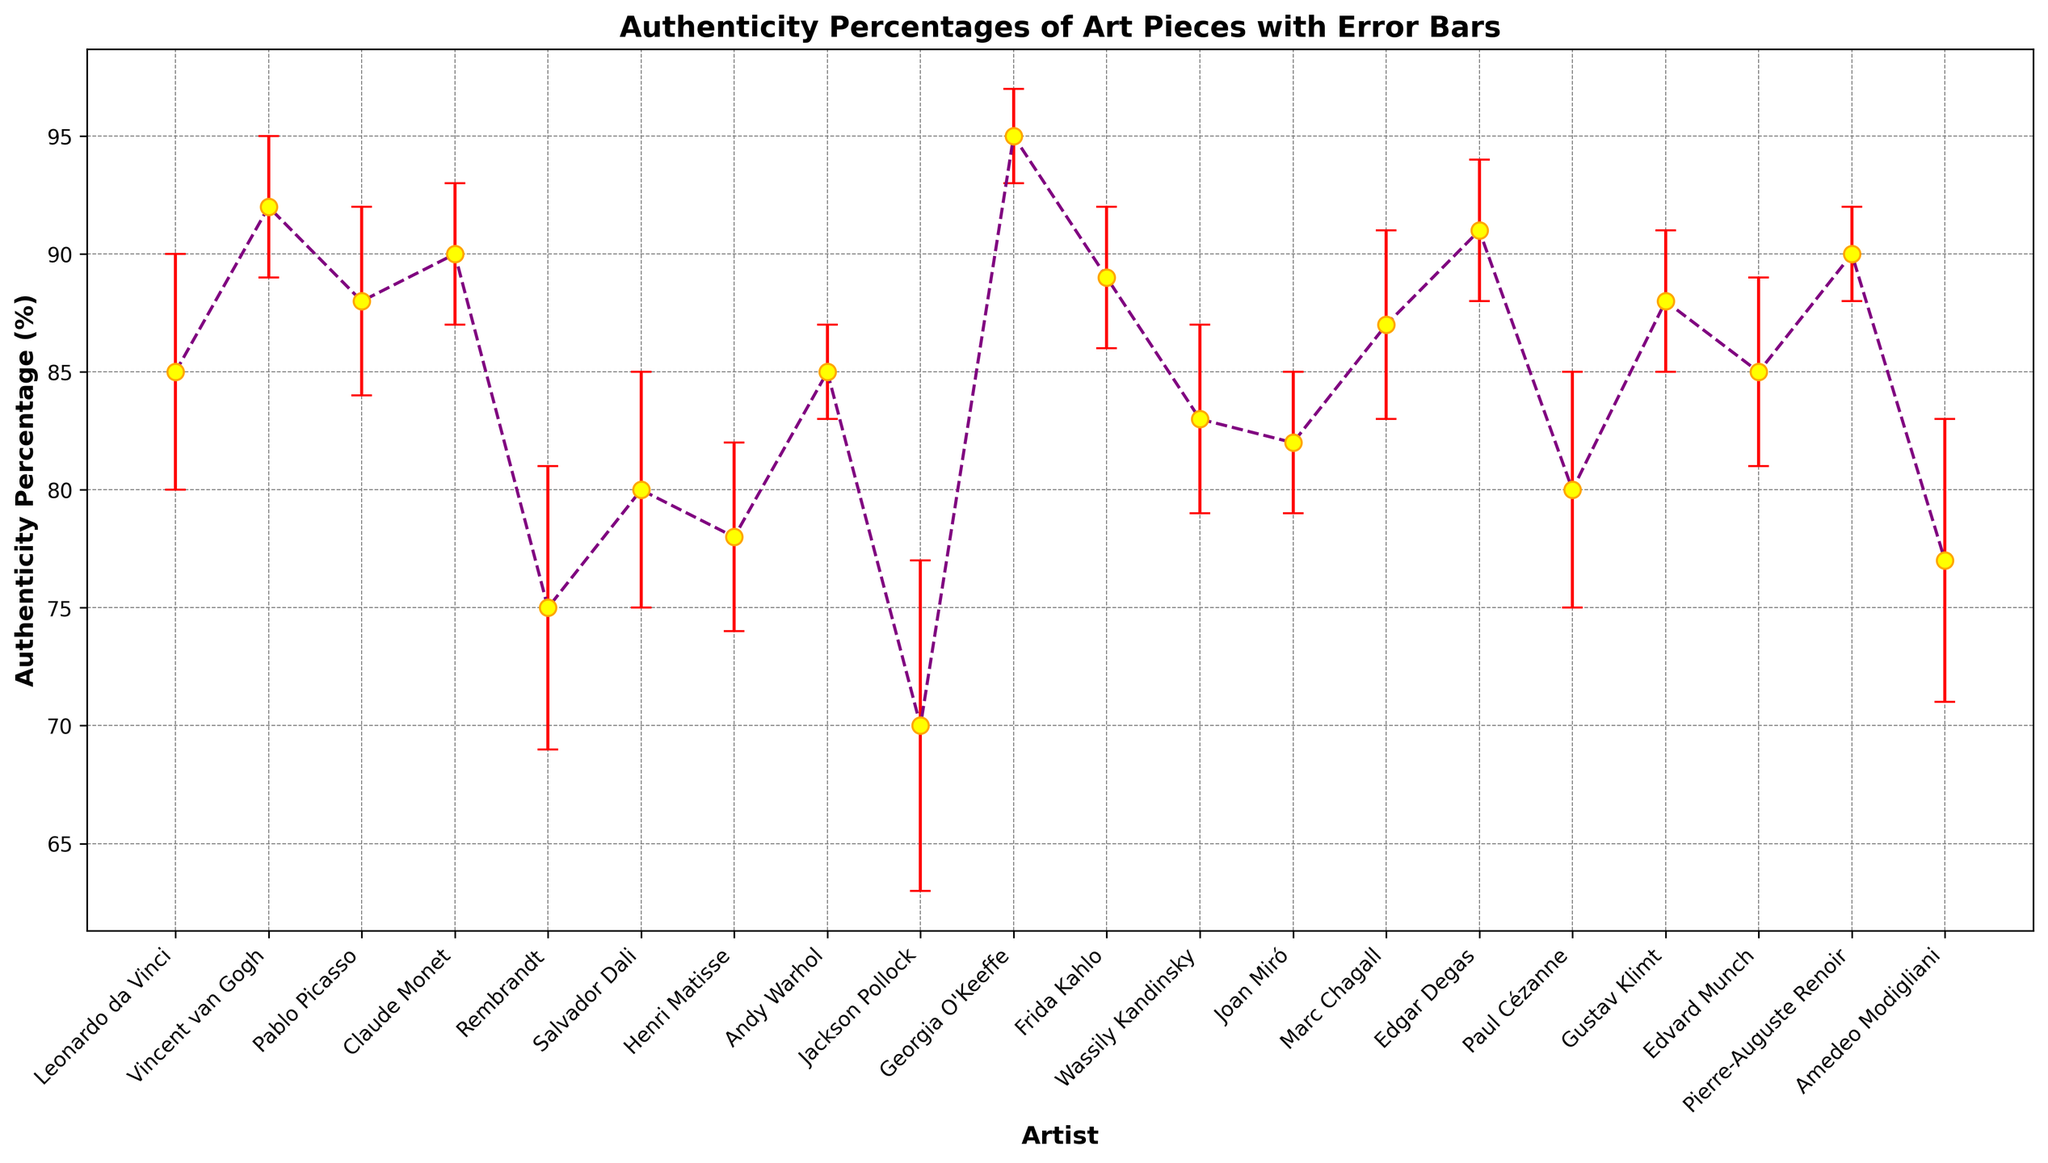What is the average authenticity percentage for Leonardo da Vinci and Pablo Picasso? To calculate the average, add the authenticity percentages of Leonardo da Vinci (85) and Pablo Picasso (88) and divide by 2: (85 + 88) / 2 = 173 / 2 = 86.5
Answer: 86.5 Which artist has the highest authenticity percentage? By scanning the authenticity percentages of all artists, Georgia O'Keeffe has the highest authenticity percentage at 95%.
Answer: Georgia O'Keeffe Are there more artists with an authenticity percentage above 85% or below 85%? Count the number of artists with authenticity percentages above 85% (Vincent van Gogh, Pablo Picasso, Claude Monet, Andy Warhol, Georgia O'Keeffe, Frida Kahlo, Edgar Degas, Pierre-Auguste Renoir, Gustav Klimt) and below 85% (Leonardo da Vinci, Rembrandt, Salvador Dali, Henri Matisse, Jackson Pollock, Wassily Kandinsky, Joan Miró, Marc Chagall, Paul Cézanne, Edvard Munch, Amedeo Modigliani): Above: 9, Below: 11
Answer: Below 85% What is the error margin for Andy Warhol's authenticity percentage? For Andy Warhol, the plotted error margin for authenticity percentage is 2.
Answer: 2 Which two artists have the same authenticity percentage? By checking the plotted values, Leonardo da Vinci and Andy Warhol both have an authenticity percentage of 85%.
Answer: Leonardo da Vinci and Andy Warhol How does the originality of Joan Miró compare to that of Marc Chagall? Joan Miró's authenticity percentage is 82%, while Marc Chagall's is 87%. Therefore, Marc Chagall's percentage is higher.
Answer: Marc Chagall's is higher What is the range of authenticity percentages among the artists? To determine the range, subtract the lowest authenticity percentage (Jackson Pollock with 70%) from the highest (Georgia O'Keeffe with 95%): 95 - 70 = 25.
Answer: 25 How many artists have an error margin of 4% or higher? By counting the number of artists with an error margin of 4 or above: Leonardo da Vinci (5), Pablo Picasso (4), Rembrandt (6), Salvador Dali (5), Henri Matisse (4), Jackson Pollock (7), Paul Cézanne (5), Amedeo Modigliani (6), Wassily Kandinsky (4), Marc Chagall (4), Edvard Munch (4). Total is 11 artists.
Answer: 11 